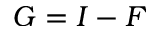<formula> <loc_0><loc_0><loc_500><loc_500>G = I - F</formula> 